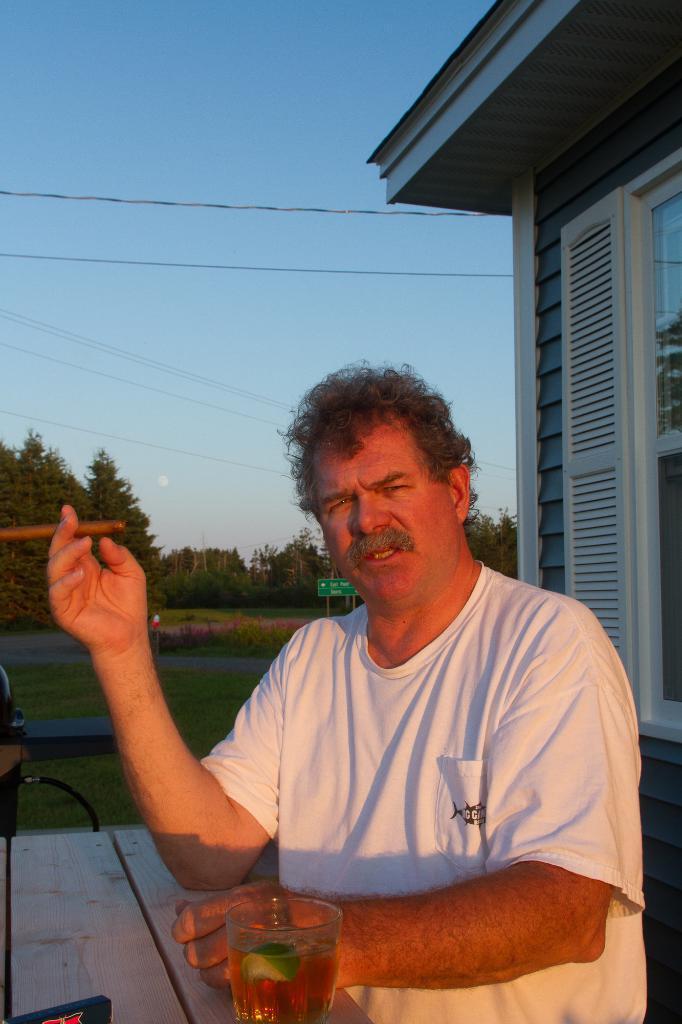Please provide a concise description of this image. In this image, there is a table, on that table there is a glass which contains wine, there is a man, he is wearing a white color t-shirt, at the right side there is a house, at the background there is grass on the ground and there are some green color trees, at the top there is a blue color sky. 